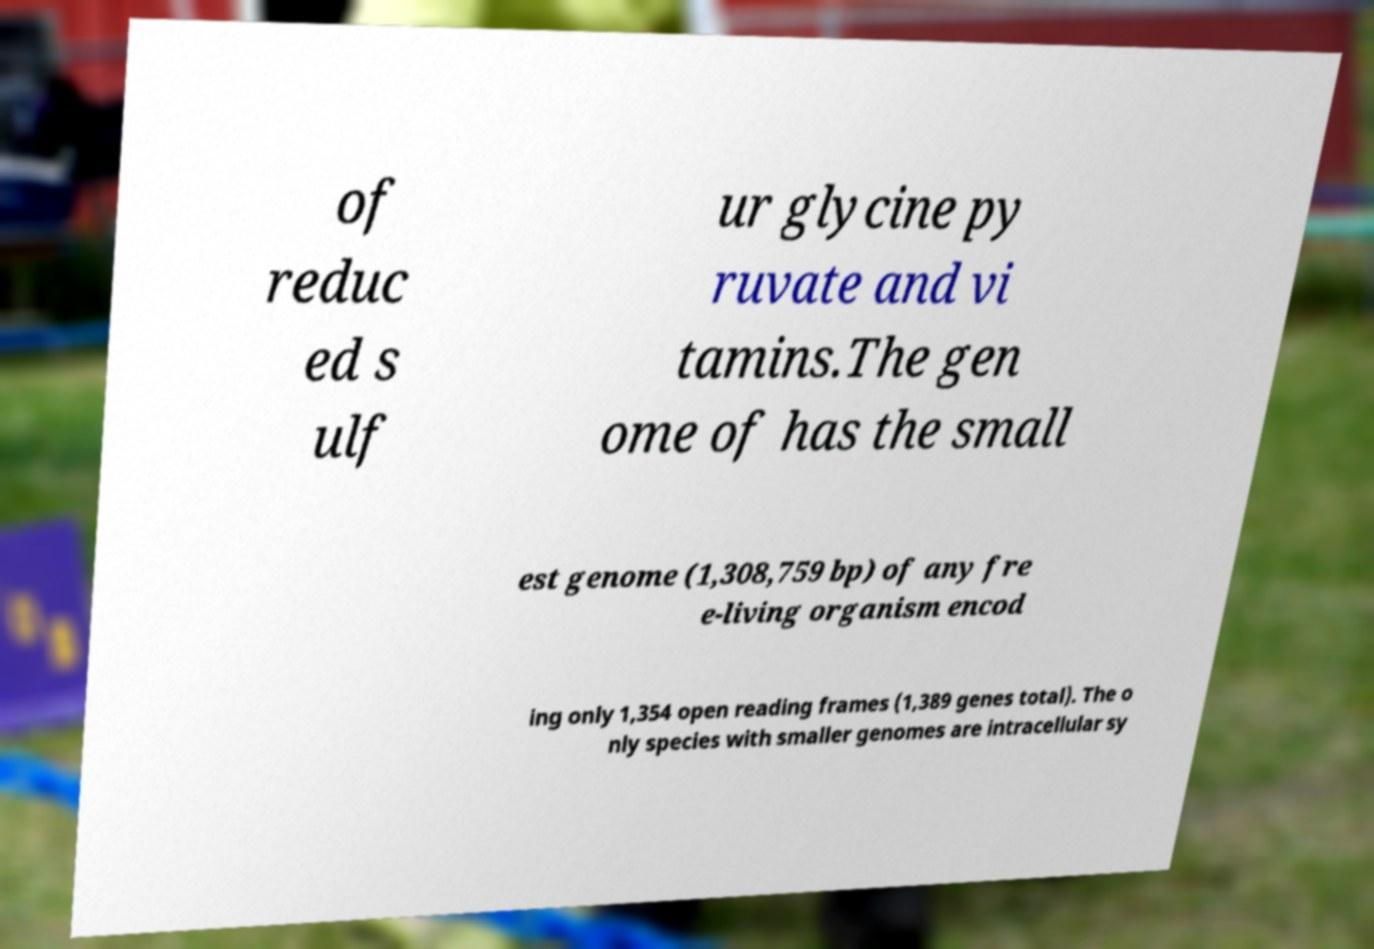There's text embedded in this image that I need extracted. Can you transcribe it verbatim? of reduc ed s ulf ur glycine py ruvate and vi tamins.The gen ome of has the small est genome (1,308,759 bp) of any fre e-living organism encod ing only 1,354 open reading frames (1,389 genes total). The o nly species with smaller genomes are intracellular sy 